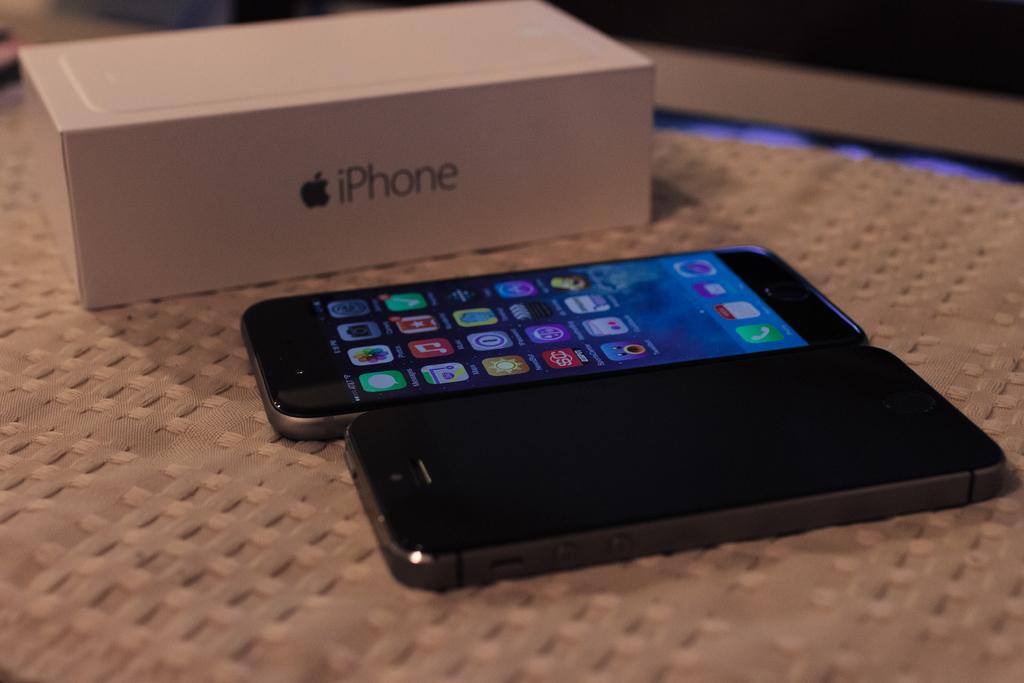What brand of smartphone is this?
Your answer should be very brief. Iphone. 